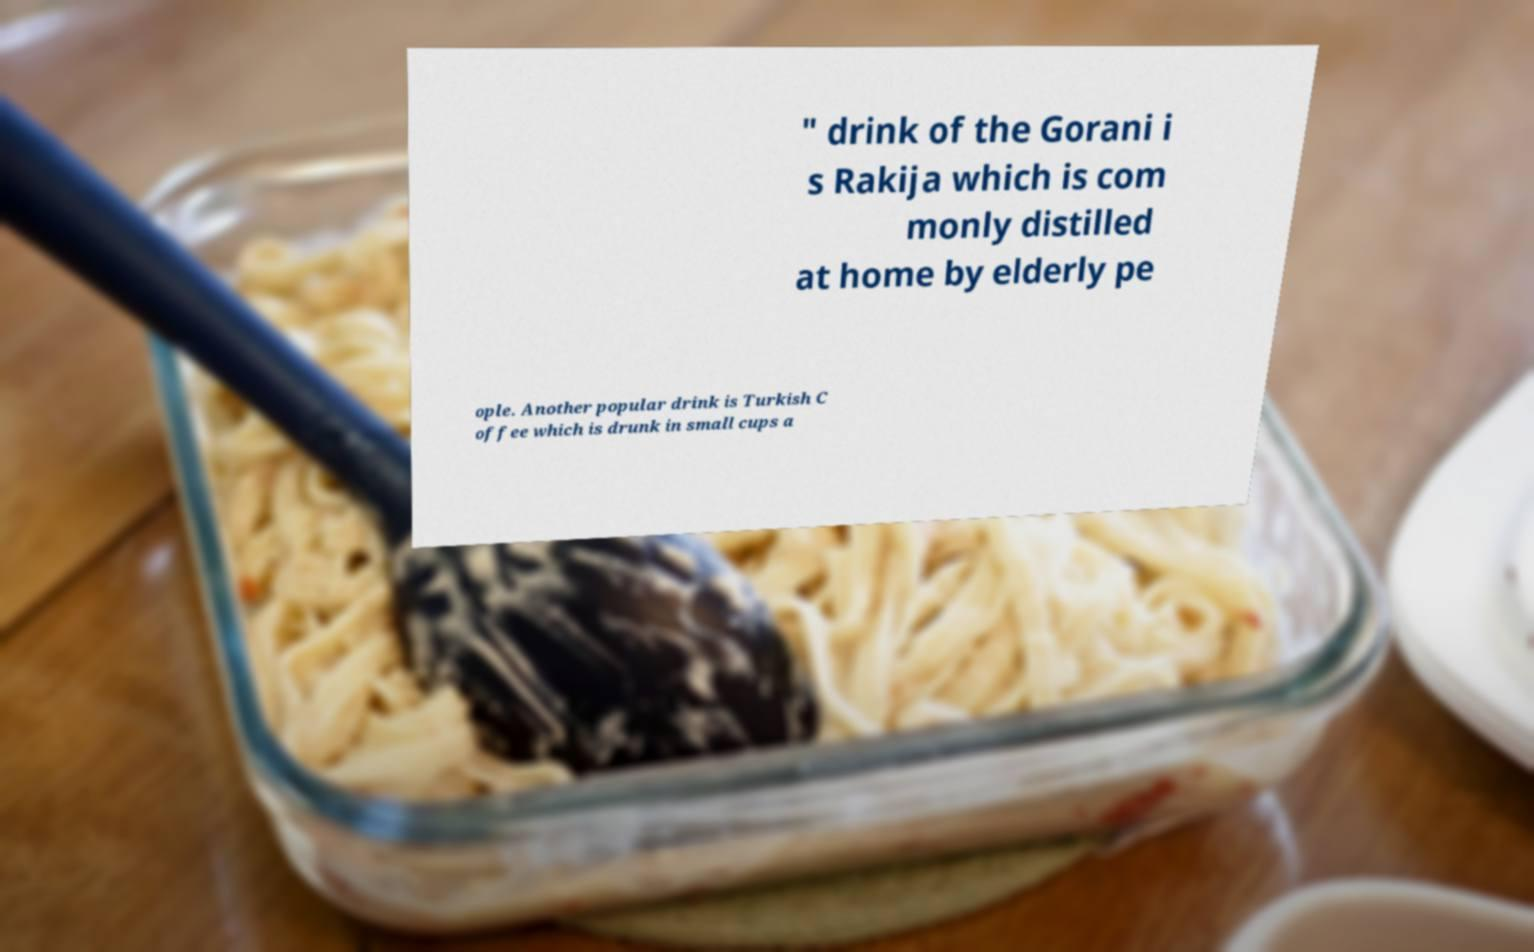Can you read and provide the text displayed in the image?This photo seems to have some interesting text. Can you extract and type it out for me? " drink of the Gorani i s Rakija which is com monly distilled at home by elderly pe ople. Another popular drink is Turkish C offee which is drunk in small cups a 